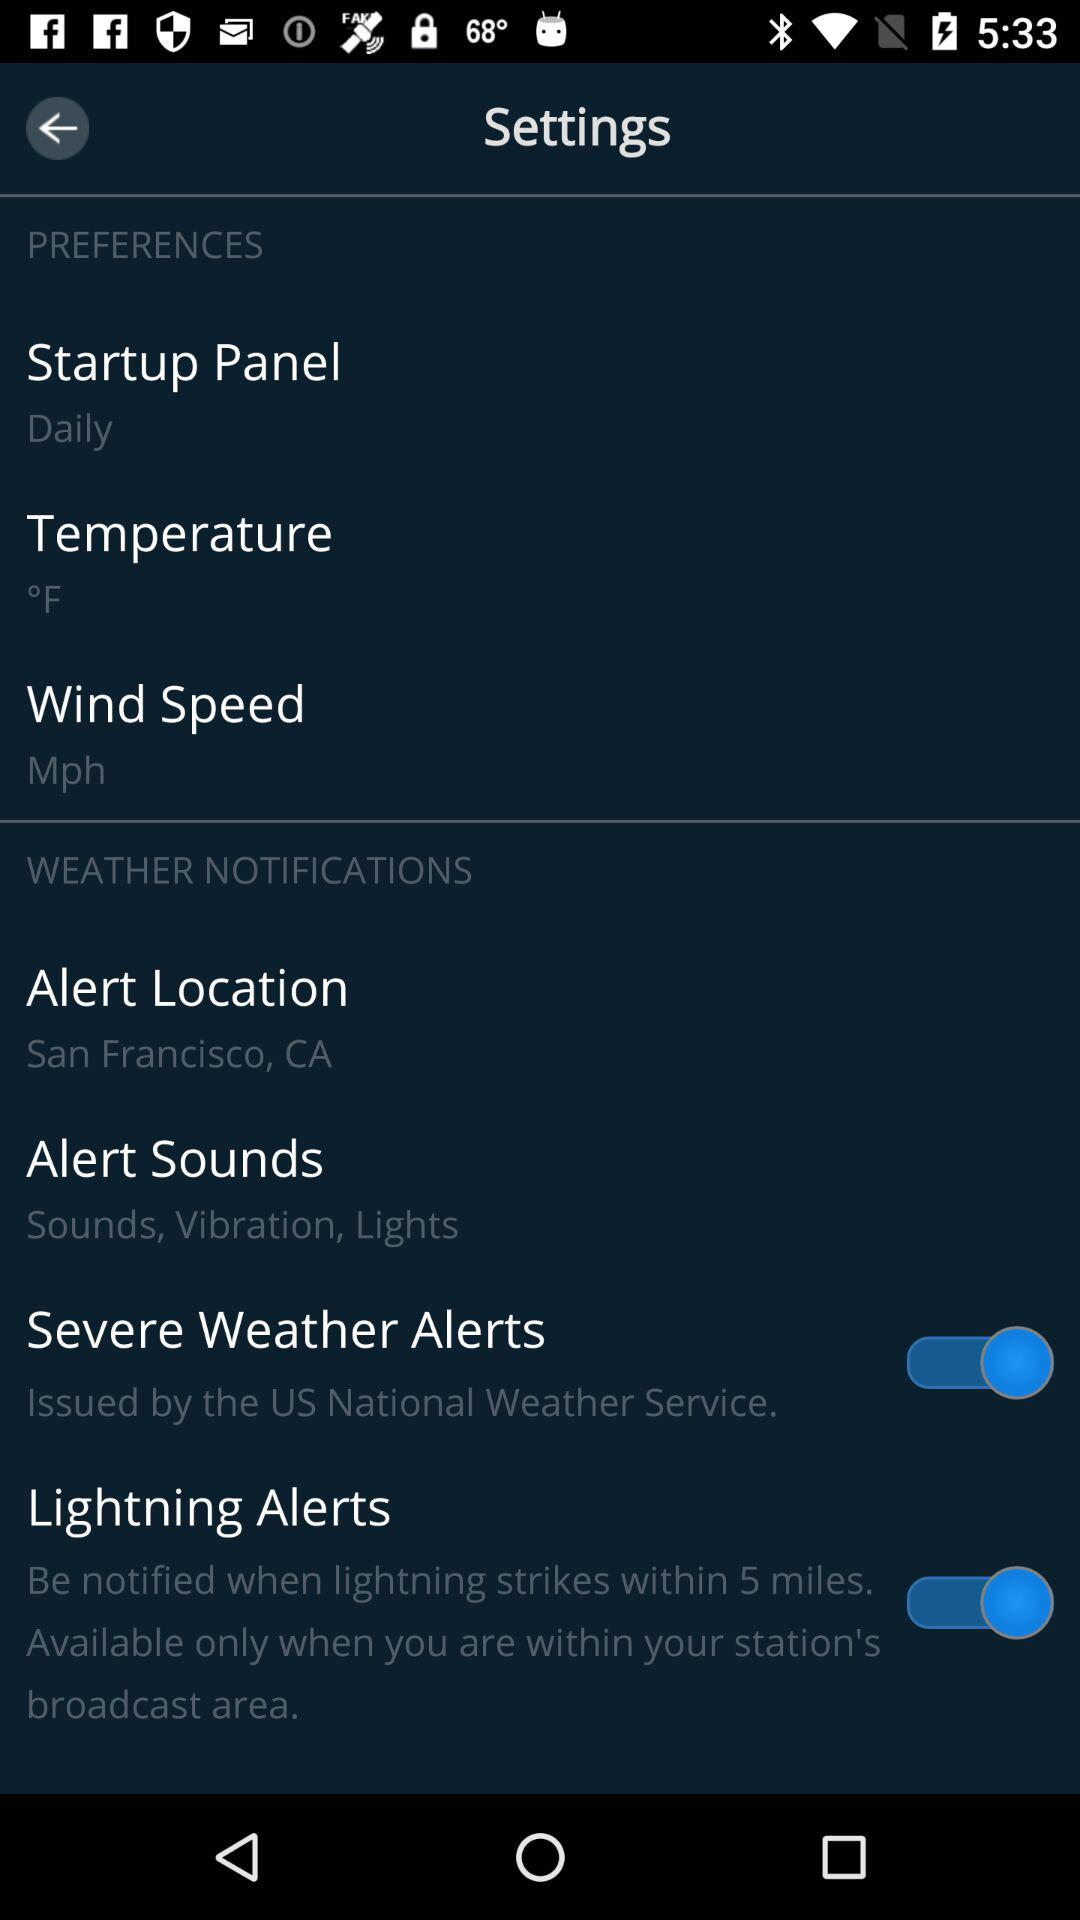How many items are in the weather notifications section?
Answer the question using a single word or phrase. 4 